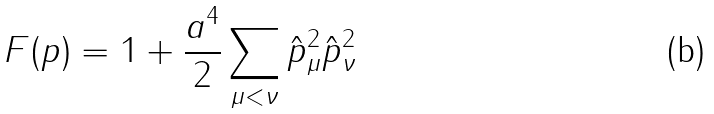<formula> <loc_0><loc_0><loc_500><loc_500>F ( p ) = 1 + \frac { a ^ { 4 } } { 2 } \sum _ { \mu < \nu } \hat { p } _ { \mu } ^ { 2 } \hat { p } _ { \nu } ^ { 2 }</formula> 